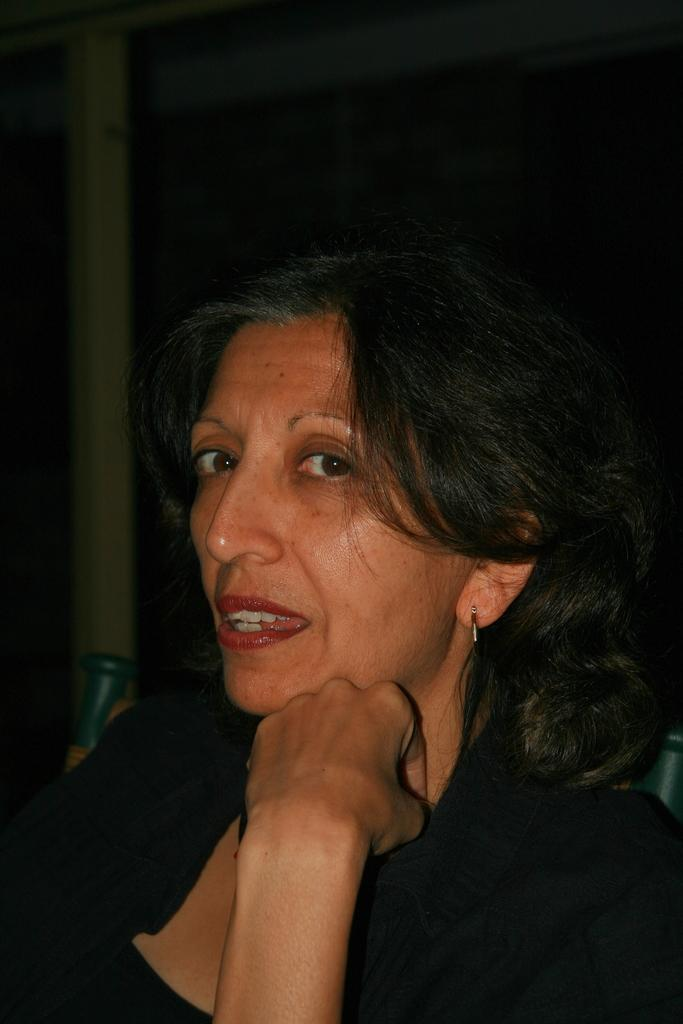Who is present in the image? There is a woman in the image. What is the woman wearing? The woman is wearing a black dress. What can be seen in the background of the image? There are other objects in the background of the image. How many feet of thread can be seen in the image? There is no thread present in the image. What type of van is visible in the background of the image? There is no van present in the image. 